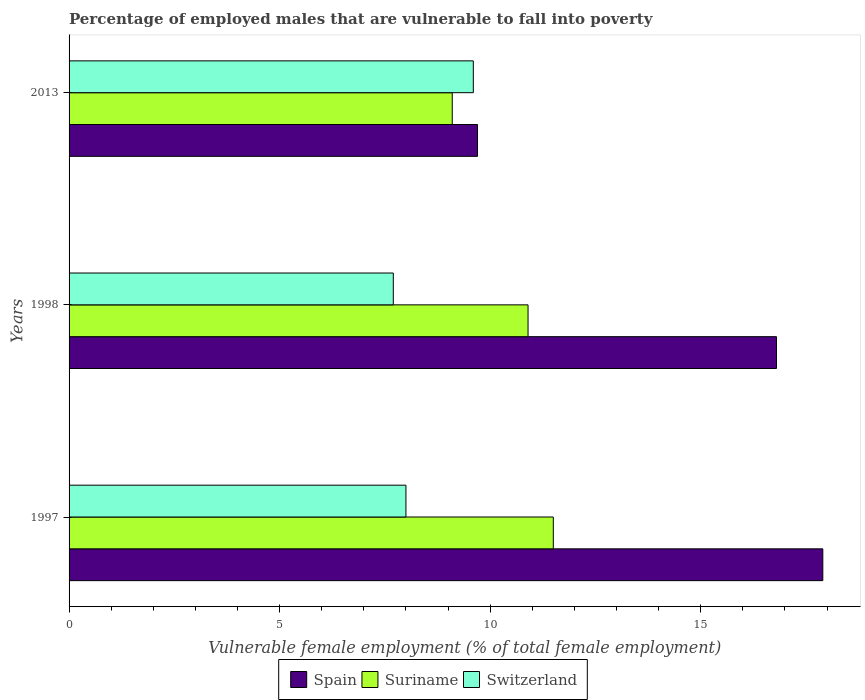How many different coloured bars are there?
Give a very brief answer. 3. Are the number of bars per tick equal to the number of legend labels?
Ensure brevity in your answer.  Yes. Are the number of bars on each tick of the Y-axis equal?
Your answer should be compact. Yes. How many bars are there on the 3rd tick from the bottom?
Make the answer very short. 3. What is the label of the 1st group of bars from the top?
Provide a succinct answer. 2013. What is the percentage of employed males who are vulnerable to fall into poverty in Suriname in 1998?
Your answer should be compact. 10.9. Across all years, what is the maximum percentage of employed males who are vulnerable to fall into poverty in Spain?
Your answer should be very brief. 17.9. Across all years, what is the minimum percentage of employed males who are vulnerable to fall into poverty in Switzerland?
Keep it short and to the point. 7.7. In which year was the percentage of employed males who are vulnerable to fall into poverty in Switzerland maximum?
Keep it short and to the point. 2013. In which year was the percentage of employed males who are vulnerable to fall into poverty in Switzerland minimum?
Make the answer very short. 1998. What is the total percentage of employed males who are vulnerable to fall into poverty in Switzerland in the graph?
Keep it short and to the point. 25.3. What is the difference between the percentage of employed males who are vulnerable to fall into poverty in Suriname in 1997 and that in 2013?
Your answer should be compact. 2.4. What is the difference between the percentage of employed males who are vulnerable to fall into poverty in Switzerland in 1997 and the percentage of employed males who are vulnerable to fall into poverty in Spain in 1998?
Provide a short and direct response. -8.8. What is the average percentage of employed males who are vulnerable to fall into poverty in Suriname per year?
Give a very brief answer. 10.5. In the year 1998, what is the difference between the percentage of employed males who are vulnerable to fall into poverty in Suriname and percentage of employed males who are vulnerable to fall into poverty in Spain?
Your answer should be compact. -5.9. In how many years, is the percentage of employed males who are vulnerable to fall into poverty in Spain greater than 4 %?
Your answer should be compact. 3. What is the ratio of the percentage of employed males who are vulnerable to fall into poverty in Spain in 1997 to that in 1998?
Your answer should be compact. 1.07. Is the percentage of employed males who are vulnerable to fall into poverty in Suriname in 1997 less than that in 1998?
Make the answer very short. No. What is the difference between the highest and the second highest percentage of employed males who are vulnerable to fall into poverty in Spain?
Offer a very short reply. 1.1. What is the difference between the highest and the lowest percentage of employed males who are vulnerable to fall into poverty in Spain?
Your response must be concise. 8.2. In how many years, is the percentage of employed males who are vulnerable to fall into poverty in Switzerland greater than the average percentage of employed males who are vulnerable to fall into poverty in Switzerland taken over all years?
Your response must be concise. 1. What does the 1st bar from the top in 2013 represents?
Provide a short and direct response. Switzerland. What does the 1st bar from the bottom in 1997 represents?
Your answer should be compact. Spain. Is it the case that in every year, the sum of the percentage of employed males who are vulnerable to fall into poverty in Suriname and percentage of employed males who are vulnerable to fall into poverty in Spain is greater than the percentage of employed males who are vulnerable to fall into poverty in Switzerland?
Your answer should be compact. Yes. How many bars are there?
Offer a very short reply. 9. Are all the bars in the graph horizontal?
Your answer should be very brief. Yes. How many years are there in the graph?
Offer a very short reply. 3. Are the values on the major ticks of X-axis written in scientific E-notation?
Ensure brevity in your answer.  No. Does the graph contain any zero values?
Offer a terse response. No. Does the graph contain grids?
Make the answer very short. No. How many legend labels are there?
Your answer should be very brief. 3. What is the title of the graph?
Make the answer very short. Percentage of employed males that are vulnerable to fall into poverty. What is the label or title of the X-axis?
Provide a short and direct response. Vulnerable female employment (% of total female employment). What is the label or title of the Y-axis?
Give a very brief answer. Years. What is the Vulnerable female employment (% of total female employment) in Spain in 1997?
Offer a terse response. 17.9. What is the Vulnerable female employment (% of total female employment) of Spain in 1998?
Keep it short and to the point. 16.8. What is the Vulnerable female employment (% of total female employment) of Suriname in 1998?
Make the answer very short. 10.9. What is the Vulnerable female employment (% of total female employment) of Switzerland in 1998?
Give a very brief answer. 7.7. What is the Vulnerable female employment (% of total female employment) in Spain in 2013?
Provide a short and direct response. 9.7. What is the Vulnerable female employment (% of total female employment) in Suriname in 2013?
Make the answer very short. 9.1. What is the Vulnerable female employment (% of total female employment) of Switzerland in 2013?
Give a very brief answer. 9.6. Across all years, what is the maximum Vulnerable female employment (% of total female employment) in Spain?
Keep it short and to the point. 17.9. Across all years, what is the maximum Vulnerable female employment (% of total female employment) in Suriname?
Offer a terse response. 11.5. Across all years, what is the maximum Vulnerable female employment (% of total female employment) of Switzerland?
Offer a terse response. 9.6. Across all years, what is the minimum Vulnerable female employment (% of total female employment) in Spain?
Your answer should be compact. 9.7. Across all years, what is the minimum Vulnerable female employment (% of total female employment) in Suriname?
Keep it short and to the point. 9.1. Across all years, what is the minimum Vulnerable female employment (% of total female employment) in Switzerland?
Offer a very short reply. 7.7. What is the total Vulnerable female employment (% of total female employment) in Spain in the graph?
Ensure brevity in your answer.  44.4. What is the total Vulnerable female employment (% of total female employment) in Suriname in the graph?
Offer a terse response. 31.5. What is the total Vulnerable female employment (% of total female employment) of Switzerland in the graph?
Keep it short and to the point. 25.3. What is the difference between the Vulnerable female employment (% of total female employment) of Suriname in 1997 and that in 1998?
Provide a succinct answer. 0.6. What is the difference between the Vulnerable female employment (% of total female employment) in Switzerland in 1997 and that in 1998?
Your response must be concise. 0.3. What is the difference between the Vulnerable female employment (% of total female employment) in Spain in 1998 and that in 2013?
Ensure brevity in your answer.  7.1. What is the difference between the Vulnerable female employment (% of total female employment) in Switzerland in 1998 and that in 2013?
Keep it short and to the point. -1.9. What is the difference between the Vulnerable female employment (% of total female employment) in Suriname in 1997 and the Vulnerable female employment (% of total female employment) in Switzerland in 1998?
Make the answer very short. 3.8. What is the difference between the Vulnerable female employment (% of total female employment) of Spain in 1998 and the Vulnerable female employment (% of total female employment) of Suriname in 2013?
Provide a short and direct response. 7.7. What is the difference between the Vulnerable female employment (% of total female employment) of Spain in 1998 and the Vulnerable female employment (% of total female employment) of Switzerland in 2013?
Make the answer very short. 7.2. What is the difference between the Vulnerable female employment (% of total female employment) of Suriname in 1998 and the Vulnerable female employment (% of total female employment) of Switzerland in 2013?
Make the answer very short. 1.3. What is the average Vulnerable female employment (% of total female employment) of Switzerland per year?
Your answer should be compact. 8.43. In the year 1998, what is the difference between the Vulnerable female employment (% of total female employment) in Spain and Vulnerable female employment (% of total female employment) in Suriname?
Provide a succinct answer. 5.9. In the year 1998, what is the difference between the Vulnerable female employment (% of total female employment) of Suriname and Vulnerable female employment (% of total female employment) of Switzerland?
Offer a terse response. 3.2. What is the ratio of the Vulnerable female employment (% of total female employment) of Spain in 1997 to that in 1998?
Your answer should be very brief. 1.07. What is the ratio of the Vulnerable female employment (% of total female employment) of Suriname in 1997 to that in 1998?
Your answer should be very brief. 1.05. What is the ratio of the Vulnerable female employment (% of total female employment) of Switzerland in 1997 to that in 1998?
Offer a very short reply. 1.04. What is the ratio of the Vulnerable female employment (% of total female employment) in Spain in 1997 to that in 2013?
Make the answer very short. 1.85. What is the ratio of the Vulnerable female employment (% of total female employment) in Suriname in 1997 to that in 2013?
Ensure brevity in your answer.  1.26. What is the ratio of the Vulnerable female employment (% of total female employment) in Switzerland in 1997 to that in 2013?
Keep it short and to the point. 0.83. What is the ratio of the Vulnerable female employment (% of total female employment) of Spain in 1998 to that in 2013?
Ensure brevity in your answer.  1.73. What is the ratio of the Vulnerable female employment (% of total female employment) of Suriname in 1998 to that in 2013?
Offer a terse response. 1.2. What is the ratio of the Vulnerable female employment (% of total female employment) in Switzerland in 1998 to that in 2013?
Make the answer very short. 0.8. What is the difference between the highest and the second highest Vulnerable female employment (% of total female employment) in Spain?
Provide a short and direct response. 1.1. What is the difference between the highest and the second highest Vulnerable female employment (% of total female employment) in Suriname?
Keep it short and to the point. 0.6. What is the difference between the highest and the lowest Vulnerable female employment (% of total female employment) of Spain?
Keep it short and to the point. 8.2. 